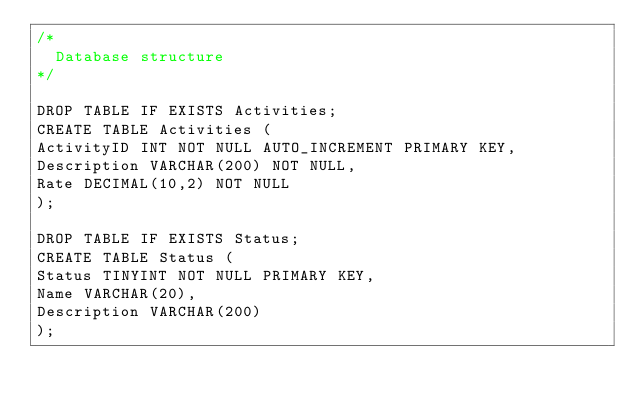Convert code to text. <code><loc_0><loc_0><loc_500><loc_500><_SQL_>/*
  Database structure
*/

DROP TABLE IF EXISTS Activities;
CREATE TABLE Activities ( 
ActivityID INT NOT NULL AUTO_INCREMENT PRIMARY KEY,
Description VARCHAR(200) NOT NULL,
Rate DECIMAL(10,2) NOT NULL
);

DROP TABLE IF EXISTS Status;
CREATE TABLE Status (
Status TINYINT NOT NULL PRIMARY KEY,
Name VARCHAR(20),
Description VARCHAR(200)
);


</code> 